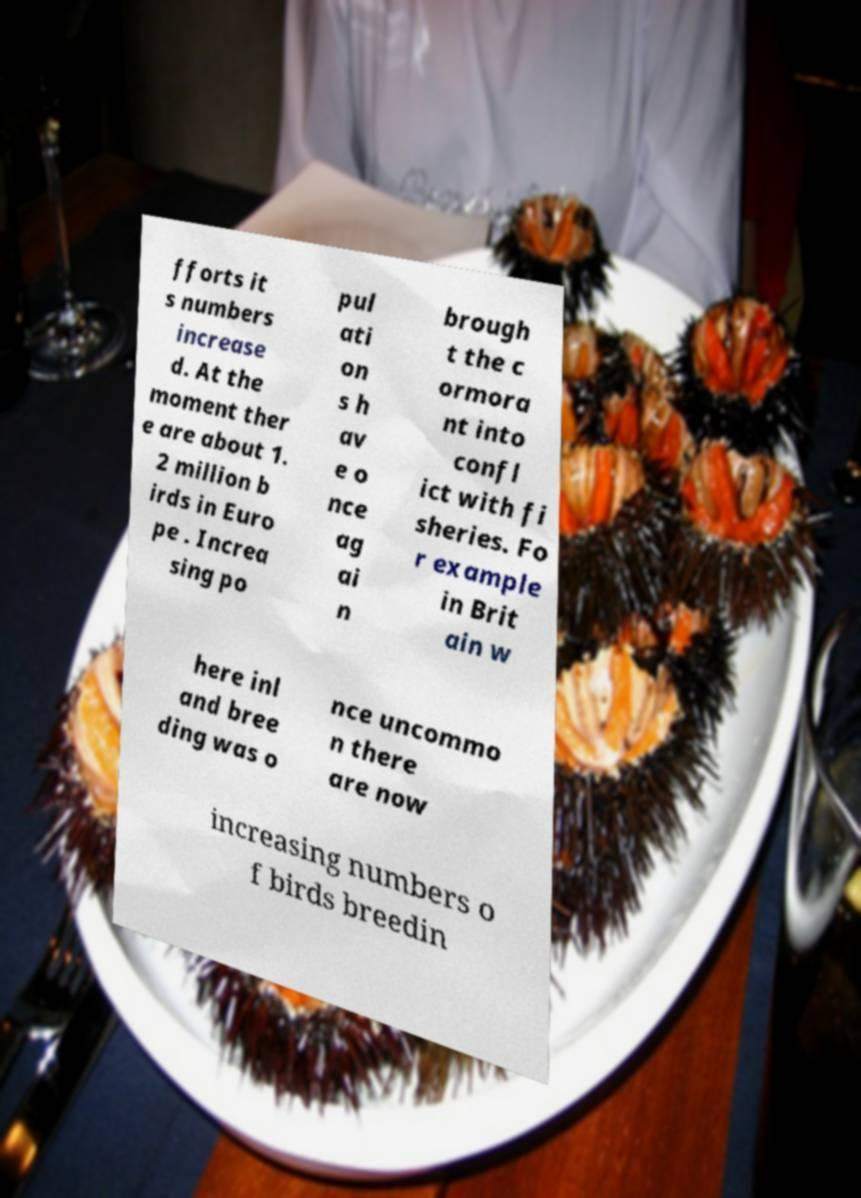There's text embedded in this image that I need extracted. Can you transcribe it verbatim? fforts it s numbers increase d. At the moment ther e are about 1. 2 million b irds in Euro pe . Increa sing po pul ati on s h av e o nce ag ai n brough t the c ormora nt into confl ict with fi sheries. Fo r example in Brit ain w here inl and bree ding was o nce uncommo n there are now increasing numbers o f birds breedin 